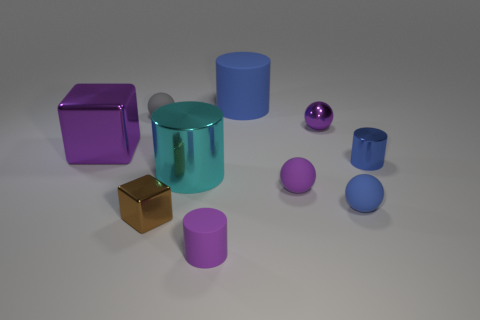What number of other objects are the same shape as the tiny brown metallic thing?
Give a very brief answer. 1. Is the size of the blue rubber object that is in front of the blue metallic object the same as the brown block on the left side of the blue ball?
Provide a short and direct response. Yes. What number of spheres are either large gray matte objects or small gray things?
Make the answer very short. 1. How many metallic objects are either blue cylinders or big brown balls?
Keep it short and to the point. 1. What size is the other metal thing that is the same shape as the gray thing?
Give a very brief answer. Small. Are there any other things that are the same size as the blue ball?
Ensure brevity in your answer.  Yes. Is the size of the brown block the same as the rubber cylinder that is in front of the big cyan metallic thing?
Give a very brief answer. Yes. There is a tiny rubber object behind the large shiny block; what shape is it?
Provide a succinct answer. Sphere. There is a big cylinder that is in front of the big cylinder to the right of the large metallic cylinder; what color is it?
Your answer should be compact. Cyan. What color is the other shiny thing that is the same shape as the large cyan shiny object?
Your answer should be very brief. Blue. 